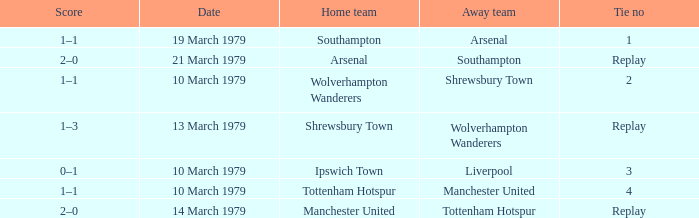What was the score for the tie that had Shrewsbury Town as home team? 1–3. 